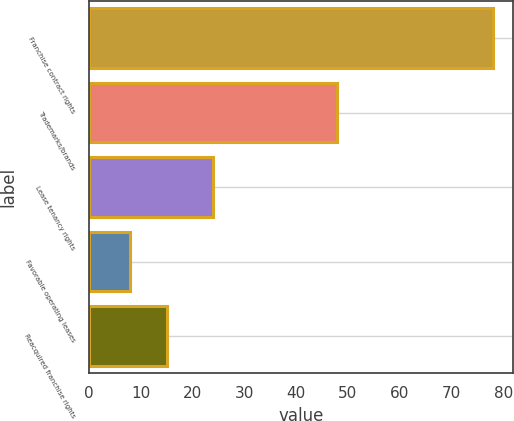Convert chart. <chart><loc_0><loc_0><loc_500><loc_500><bar_chart><fcel>Franchise contract rights<fcel>Trademarks/brands<fcel>Lease tenancy rights<fcel>Favorable operating leases<fcel>Reacquired franchise rights<nl><fcel>78<fcel>48<fcel>24<fcel>8<fcel>15<nl></chart> 